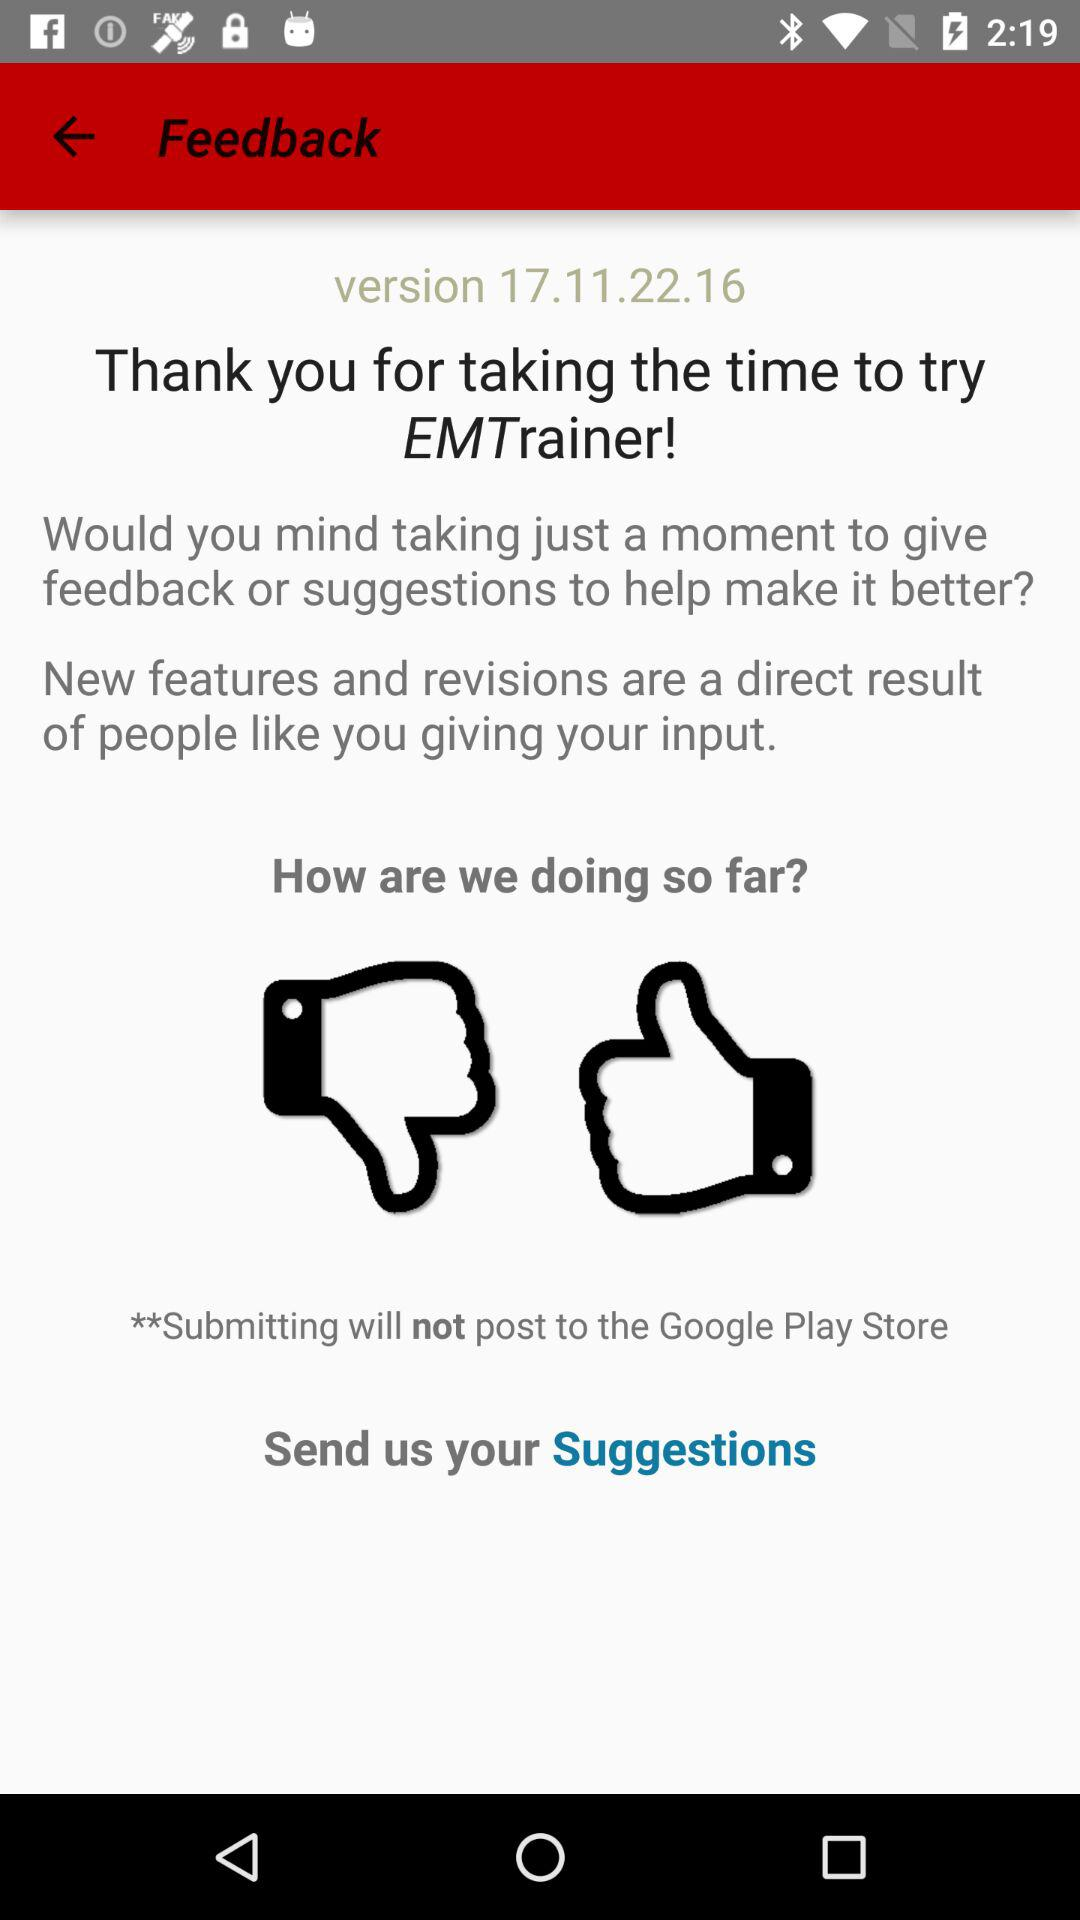How many positive reviews does "EMTrainer" have?
When the provided information is insufficient, respond with <no answer>. <no answer> 